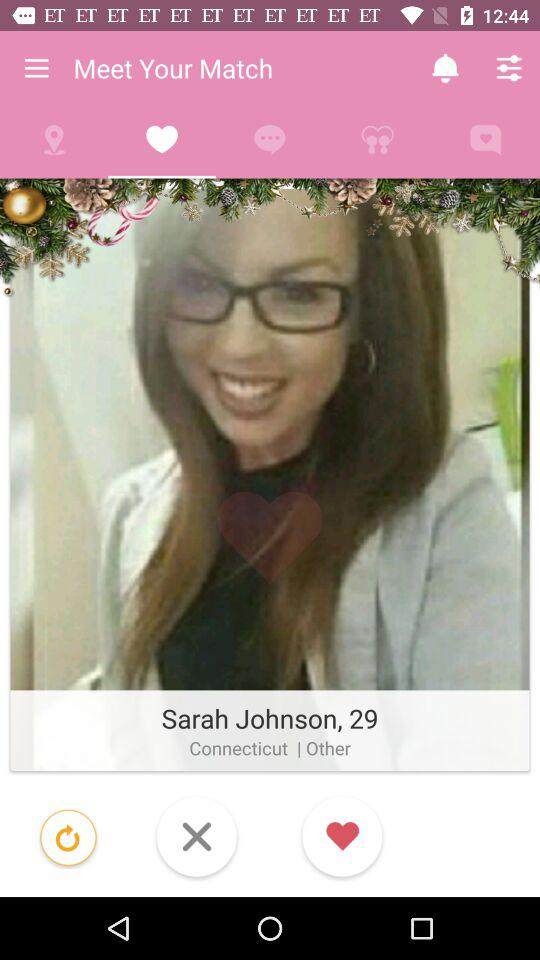What is the name of the person? The name of the person is Sarah Johnson. 